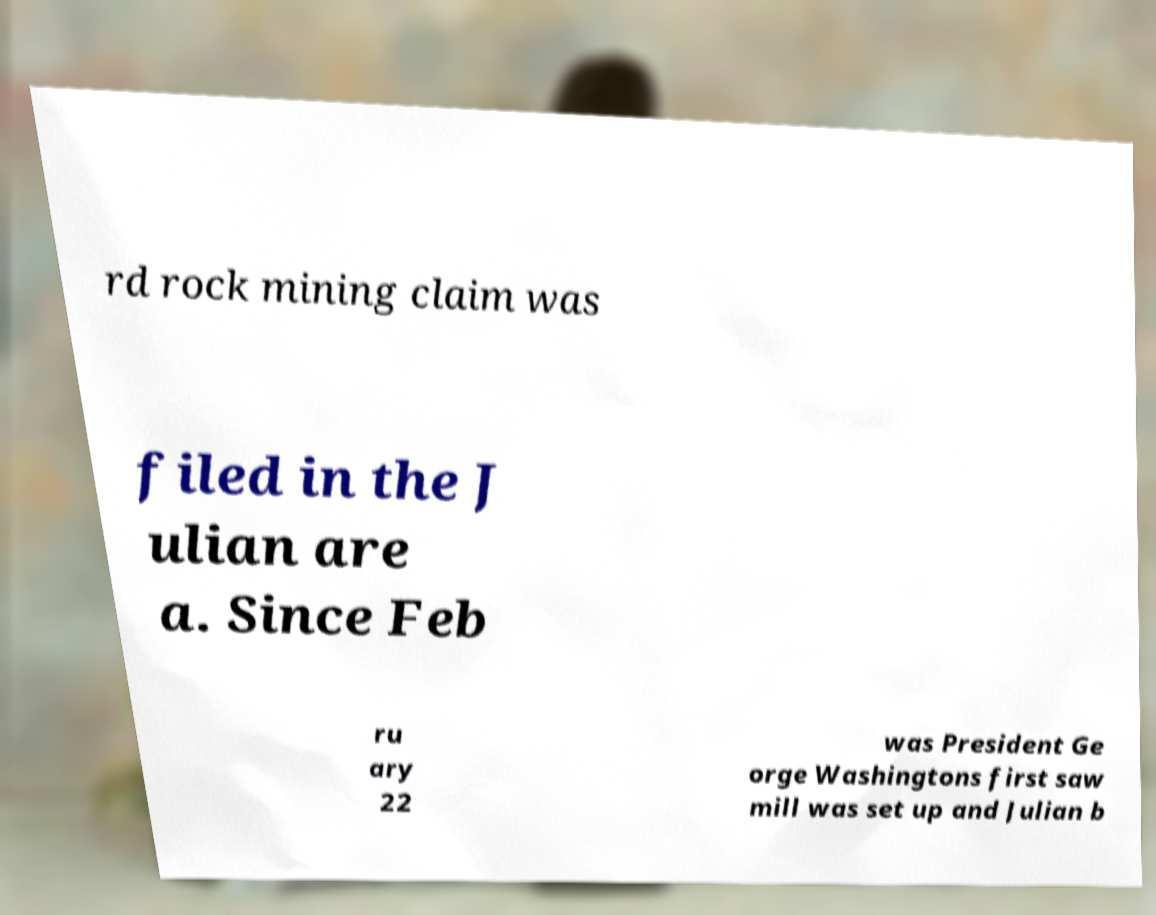There's text embedded in this image that I need extracted. Can you transcribe it verbatim? rd rock mining claim was filed in the J ulian are a. Since Feb ru ary 22 was President Ge orge Washingtons first saw mill was set up and Julian b 